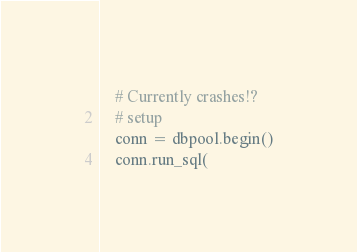Convert code to text. <code><loc_0><loc_0><loc_500><loc_500><_Python_>    # Currently crashes!?
    # setup
    conn = dbpool.begin()
    conn.run_sql(</code> 